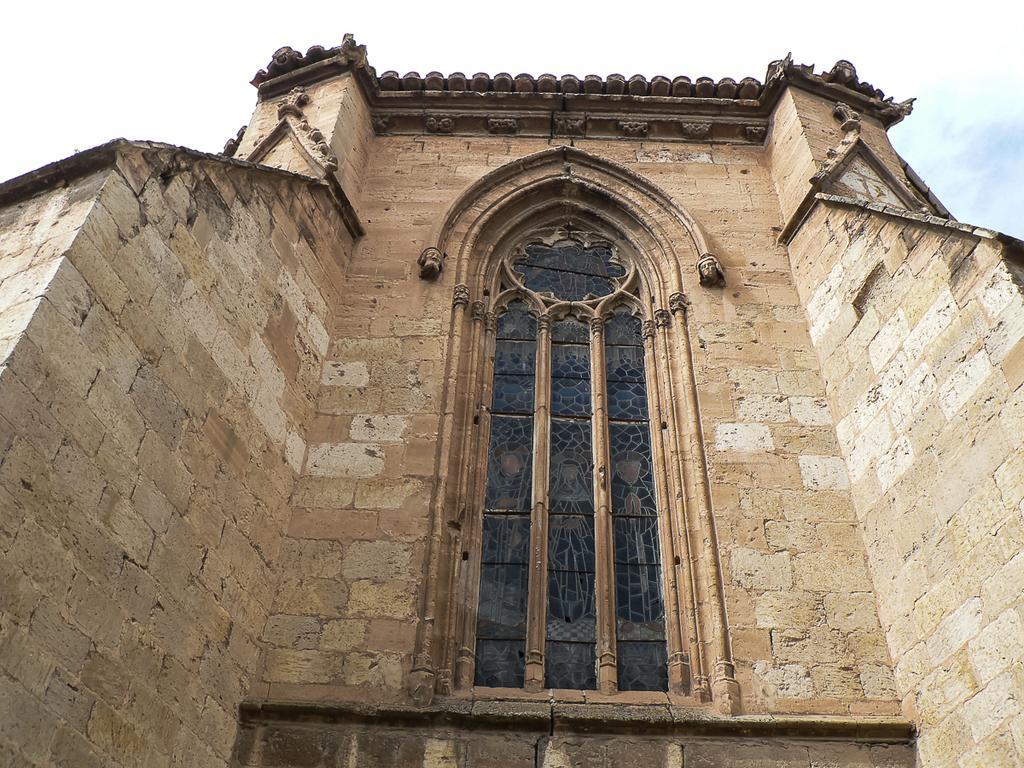What type of building is in the image? There is a cream-colored building in the image. What can be seen in the background of the image? The sky is visible in the image. What type of window is present in the building? There is a glass window in the image. What time of day is the recess taking place in the image? There is no indication of a recess or any activity involving people in the image. 